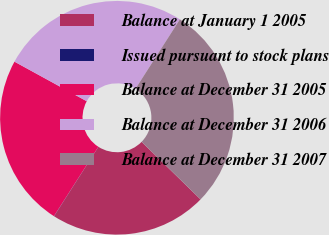Convert chart to OTSL. <chart><loc_0><loc_0><loc_500><loc_500><pie_chart><fcel>Balance at January 1 2005<fcel>Issued pursuant to stock plans<fcel>Balance at December 31 2005<fcel>Balance at December 31 2006<fcel>Balance at December 31 2007<nl><fcel>21.73%<fcel>0.03%<fcel>23.91%<fcel>26.08%<fcel>28.25%<nl></chart> 